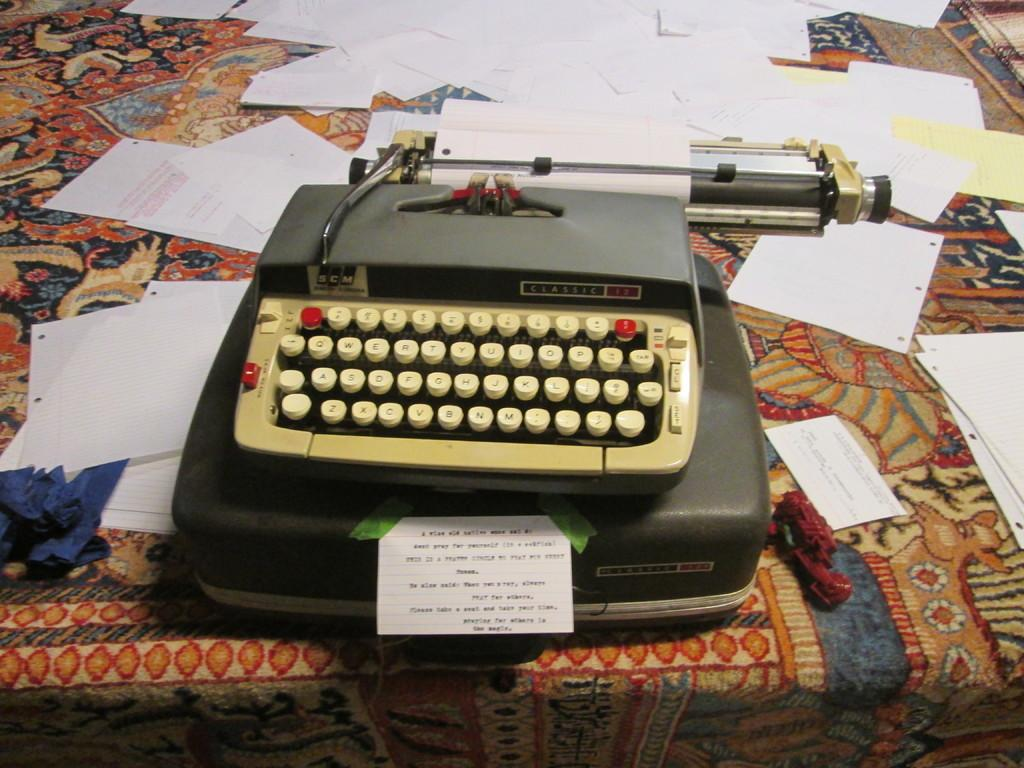Provide a one-sentence caption for the provided image. An antique SCM Classic typewriter with papers scattered about it. 